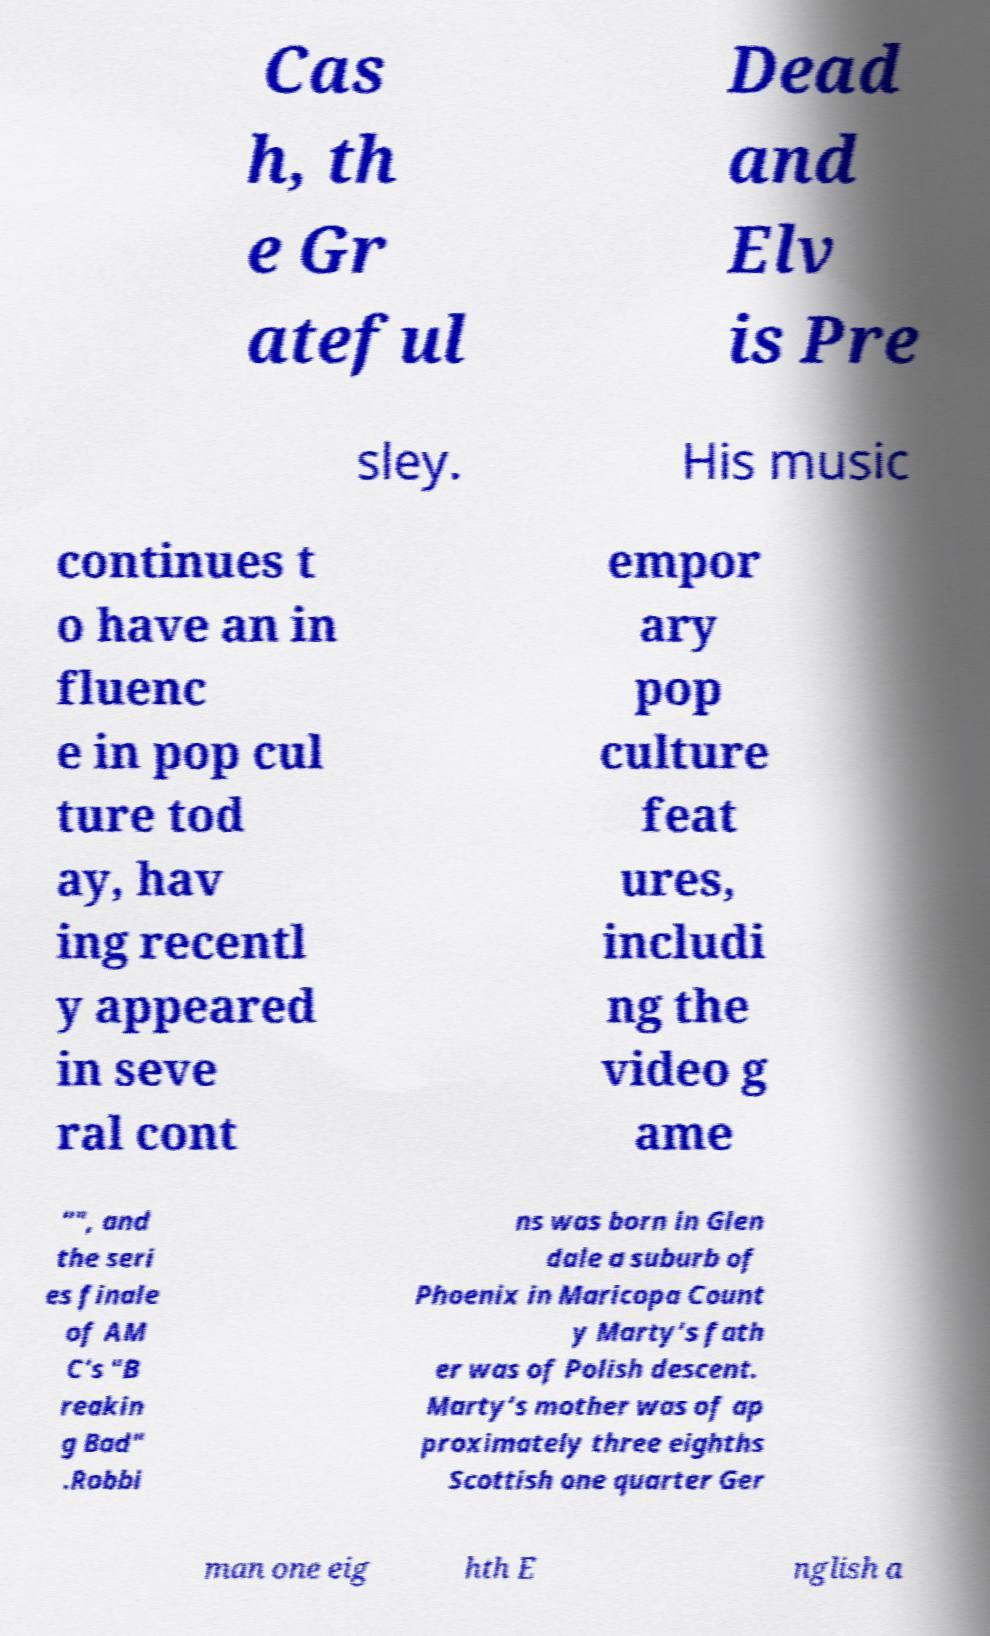What messages or text are displayed in this image? I need them in a readable, typed format. Cas h, th e Gr ateful Dead and Elv is Pre sley. His music continues t o have an in fluenc e in pop cul ture tod ay, hav ing recentl y appeared in seve ral cont empor ary pop culture feat ures, includi ng the video g ame "", and the seri es finale of AM C's "B reakin g Bad" .Robbi ns was born in Glen dale a suburb of Phoenix in Maricopa Count y Marty’s fath er was of Polish descent. Marty’s mother was of ap proximately three eighths Scottish one quarter Ger man one eig hth E nglish a 